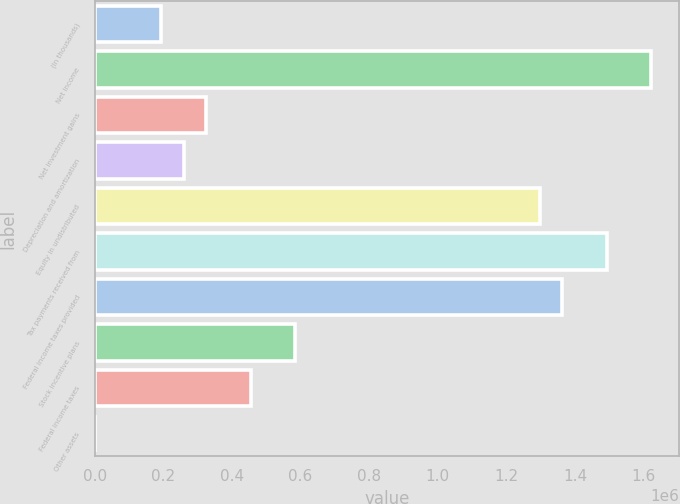<chart> <loc_0><loc_0><loc_500><loc_500><bar_chart><fcel>(In thousands)<fcel>Net income<fcel>Net investment gains<fcel>Depreciation and amortization<fcel>Equity in undistributed<fcel>Tax payments received from<fcel>Federal income taxes provided<fcel>Stock incentive plans<fcel>Federal income taxes<fcel>Other assets<nl><fcel>194920<fcel>1.62166e+06<fcel>324624<fcel>259772<fcel>1.2974e+06<fcel>1.49196e+06<fcel>1.36226e+06<fcel>584032<fcel>454328<fcel>364<nl></chart> 